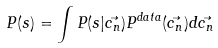Convert formula to latex. <formula><loc_0><loc_0><loc_500><loc_500>P ( s ) = \int P ( s | \vec { c _ { n } } ) P ^ { d a t a } ( \vec { c _ { n } } ) d \vec { c _ { n } }</formula> 